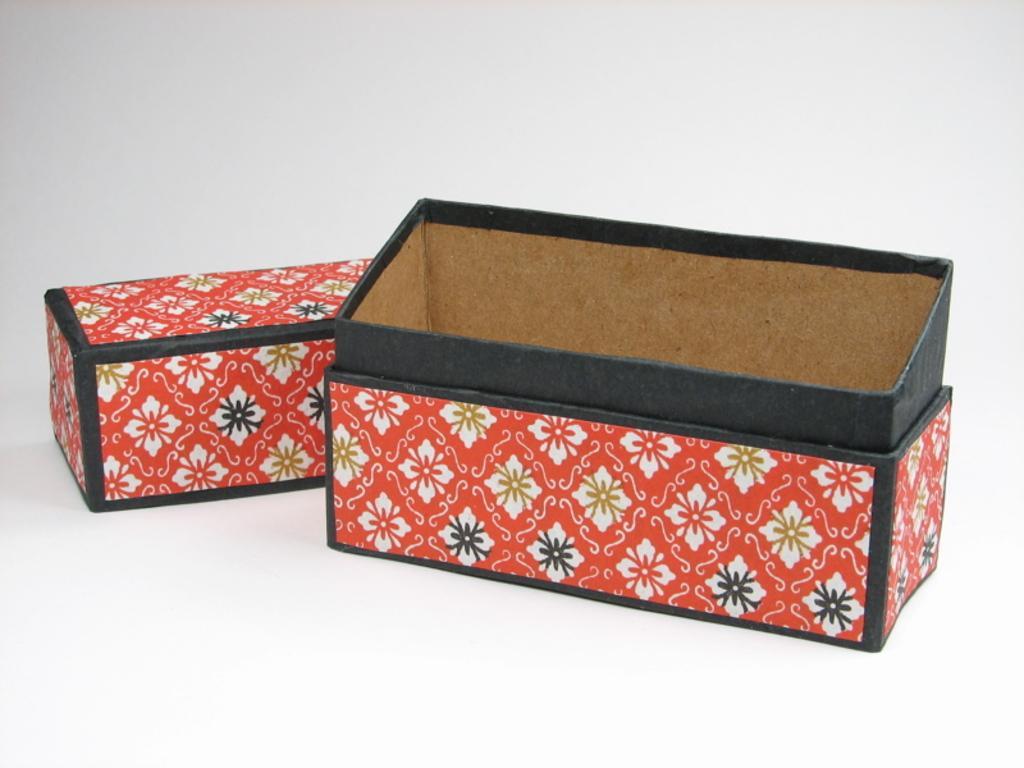Could you give a brief overview of what you see in this image? In this picture I can see few cardboard boxes and I can see white color background. 